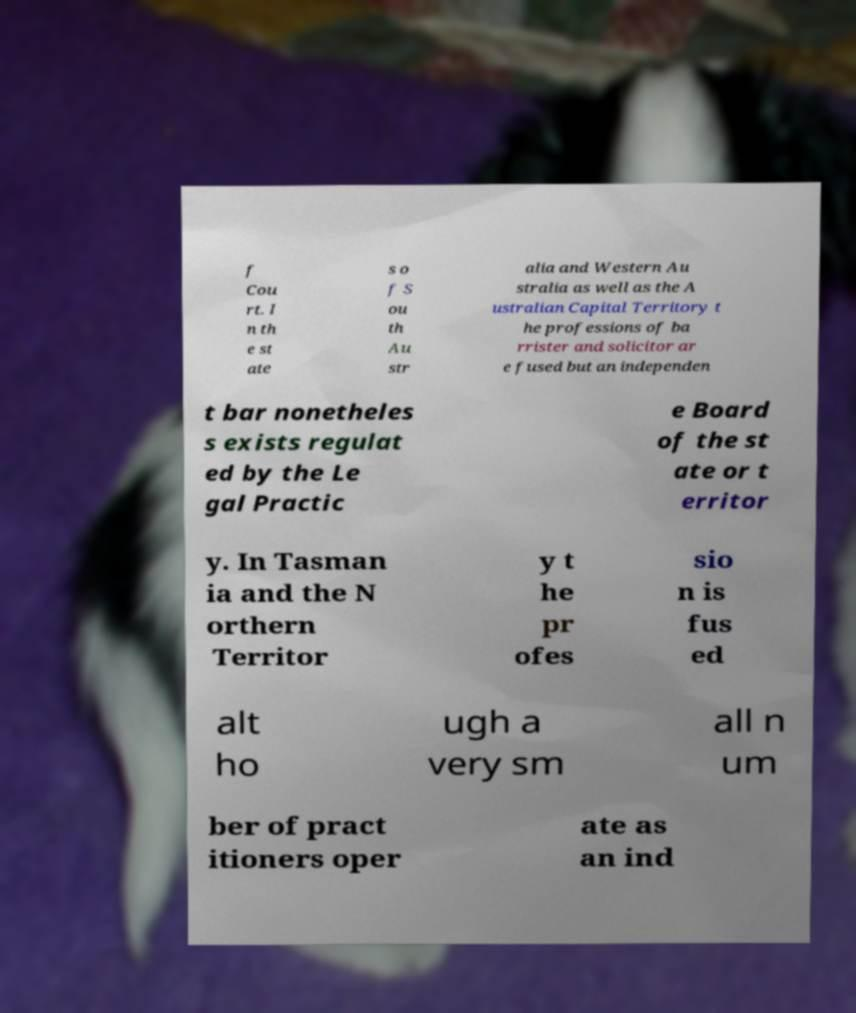For documentation purposes, I need the text within this image transcribed. Could you provide that? f Cou rt. I n th e st ate s o f S ou th Au str alia and Western Au stralia as well as the A ustralian Capital Territory t he professions of ba rrister and solicitor ar e fused but an independen t bar nonetheles s exists regulat ed by the Le gal Practic e Board of the st ate or t erritor y. In Tasman ia and the N orthern Territor y t he pr ofes sio n is fus ed alt ho ugh a very sm all n um ber of pract itioners oper ate as an ind 